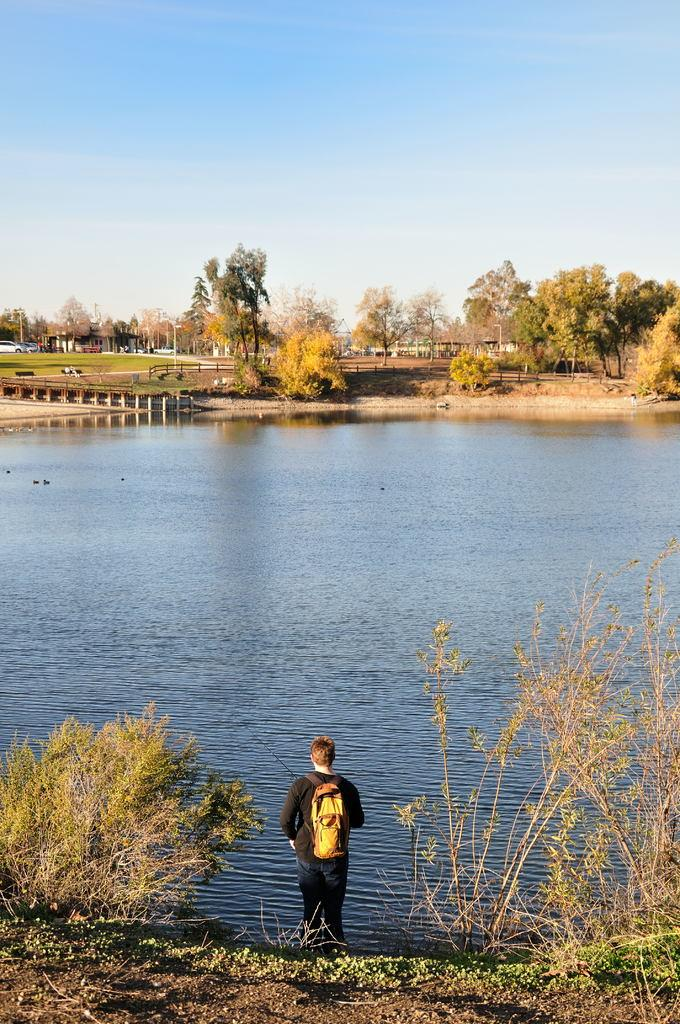What is the primary element visible in the image? There is water in the image. What is the person wearing in the image? The person is wearing a bag in the image. What type of vegetation can be seen in the image? There are plants in the image, and trees can be seen in the background. What is the condition of the grass in the background of the image? The grass in the background is green. What is visible in the sky in the background of the image? The sky is clear and visible in the background of the image. What type of light can be seen emanating from the zephyr in the image? There is no zephyr or light present in the image. What type of maid is attending to the person wearing a bag in the image? There is no maid present in the image; it only shows a person wearing a bag. 